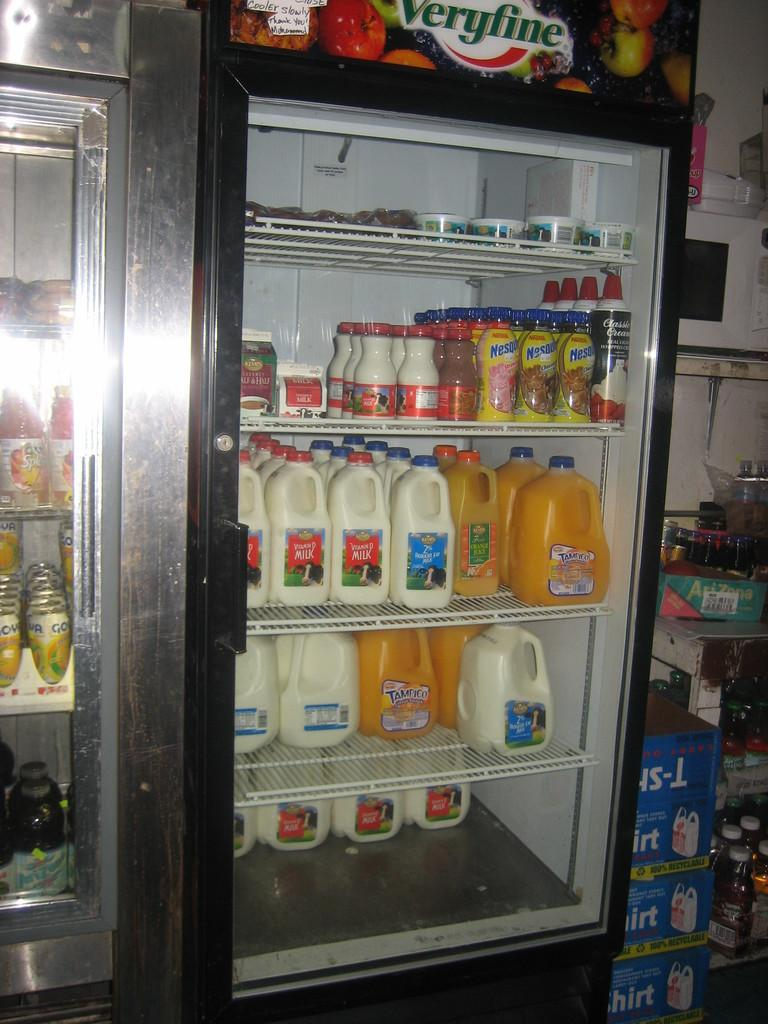<image>
Describe the image concisely. A refrigerated display at a store with Tampico juice, milk and Nestle flavored milk. 